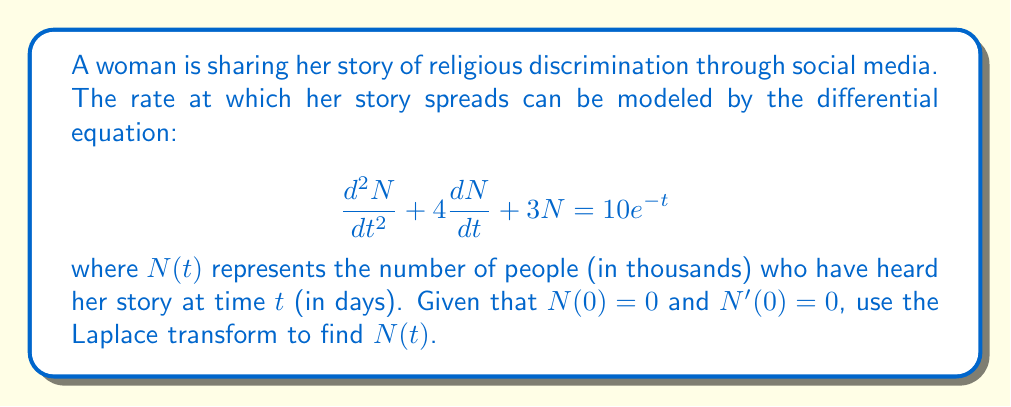Help me with this question. Let's solve this problem step by step using the Laplace transform:

1) Take the Laplace transform of both sides of the equation:
   $$\mathcal{L}\left\{\frac{d^2N}{dt^2} + 4\frac{dN}{dt} + 3N\right\} = \mathcal{L}\{10e^{-t}\}$$

2) Using Laplace transform properties:
   $$s^2N(s) - sN(0) - N'(0) + 4(sN(s) - N(0)) + 3N(s) = \frac{10}{s+1}$$

3) Given initial conditions $N(0) = 0$ and $N'(0) = 0$:
   $$s^2N(s) + 4sN(s) + 3N(s) = \frac{10}{s+1}$$

4) Factoring out $N(s)$:
   $$N(s)(s^2 + 4s + 3) = \frac{10}{s+1}$$

5) Solving for $N(s)$:
   $$N(s) = \frac{10}{(s+1)(s^2 + 4s + 3)}$$

6) Decompose the right-hand side into partial fractions:
   $$N(s) = \frac{A}{s+1} + \frac{Bs+C}{s^2 + 4s + 3}$$

7) Solving for $A$, $B$, and $C$:
   $$A = \frac{10}{6}, B = -\frac{5}{3}, C = -\frac{10}{3}$$

8) Rewrite $N(s)$:
   $$N(s) = \frac{5}{3(s+1)} - \frac{5(s+2)}{3(s^2 + 4s + 3)}$$

9) Take the inverse Laplace transform:
   $$N(t) = \frac{5}{3}e^{-t} - \frac{5}{3}e^{-2t}(1+t)$$

This is the solution for $N(t)$.
Answer: $$N(t) = \frac{5}{3}e^{-t} - \frac{5}{3}e^{-2t}(1+t)$$ 